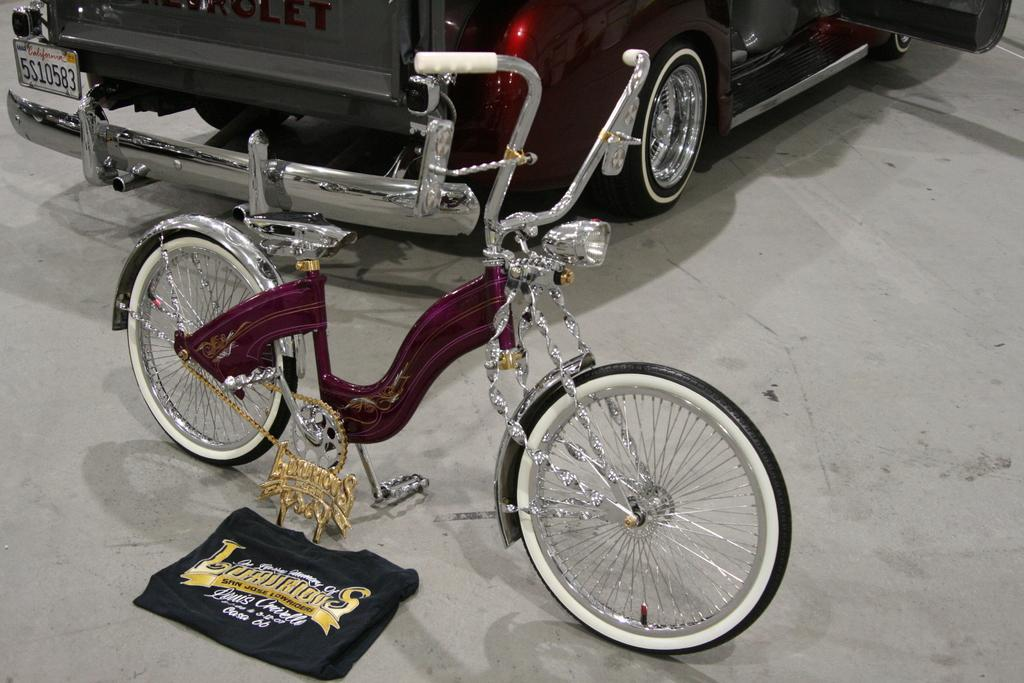What is the main subject of the image? The main subject of the image is a bicycle. What colors can be seen on the bicycle? The bicycle has purple, silver, and gold colors. What else is present in the image besides the bicycle? There is a vehicle to the side of the bicycle and cloth on the floor in the image. Can you see a circle of crows flying around the bicycle in the image? No, there are no crows or circles present in the image. 